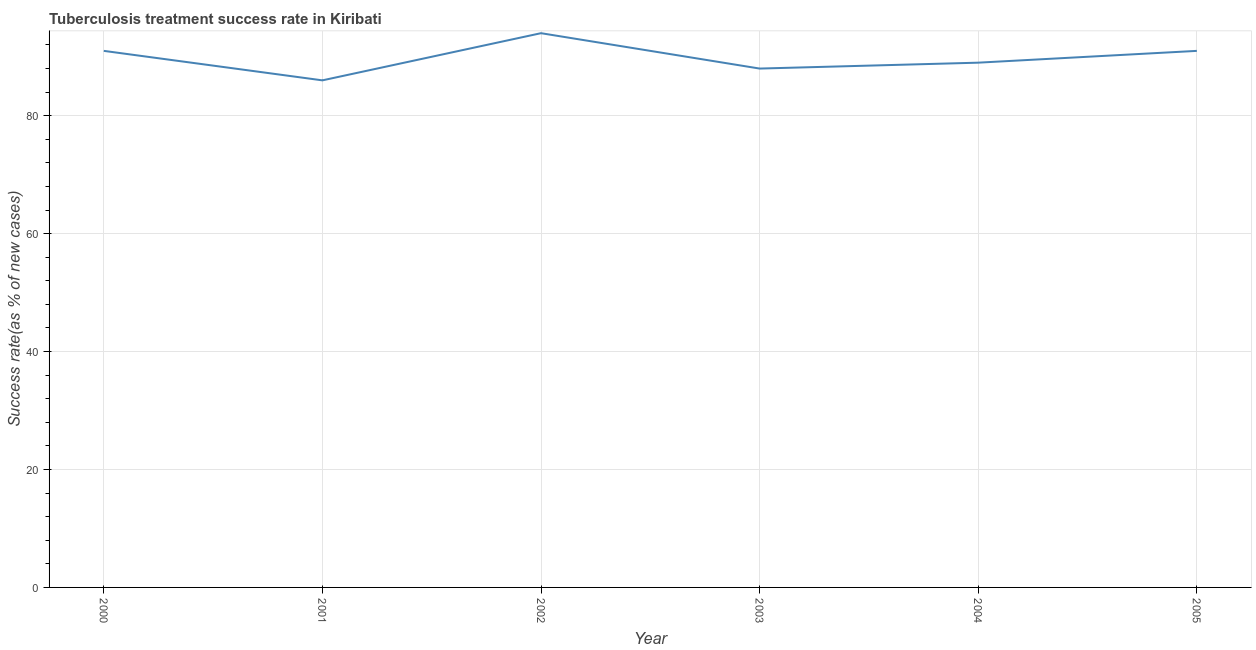What is the tuberculosis treatment success rate in 2001?
Make the answer very short. 86. Across all years, what is the maximum tuberculosis treatment success rate?
Offer a very short reply. 94. Across all years, what is the minimum tuberculosis treatment success rate?
Provide a succinct answer. 86. In which year was the tuberculosis treatment success rate minimum?
Keep it short and to the point. 2001. What is the sum of the tuberculosis treatment success rate?
Offer a terse response. 539. What is the difference between the tuberculosis treatment success rate in 2000 and 2005?
Your response must be concise. 0. What is the average tuberculosis treatment success rate per year?
Offer a terse response. 89.83. What is the median tuberculosis treatment success rate?
Your answer should be compact. 90. Do a majority of the years between 2001 and 2004 (inclusive) have tuberculosis treatment success rate greater than 68 %?
Offer a very short reply. Yes. What is the ratio of the tuberculosis treatment success rate in 2002 to that in 2005?
Offer a terse response. 1.03. Is the tuberculosis treatment success rate in 2001 less than that in 2003?
Ensure brevity in your answer.  Yes. Is the difference between the tuberculosis treatment success rate in 2001 and 2002 greater than the difference between any two years?
Give a very brief answer. Yes. What is the difference between the highest and the lowest tuberculosis treatment success rate?
Give a very brief answer. 8. In how many years, is the tuberculosis treatment success rate greater than the average tuberculosis treatment success rate taken over all years?
Give a very brief answer. 3. Does the tuberculosis treatment success rate monotonically increase over the years?
Provide a succinct answer. No. How many lines are there?
Provide a short and direct response. 1. How many years are there in the graph?
Your response must be concise. 6. Are the values on the major ticks of Y-axis written in scientific E-notation?
Give a very brief answer. No. Does the graph contain any zero values?
Give a very brief answer. No. What is the title of the graph?
Make the answer very short. Tuberculosis treatment success rate in Kiribati. What is the label or title of the Y-axis?
Make the answer very short. Success rate(as % of new cases). What is the Success rate(as % of new cases) in 2000?
Offer a terse response. 91. What is the Success rate(as % of new cases) in 2001?
Provide a succinct answer. 86. What is the Success rate(as % of new cases) in 2002?
Your answer should be very brief. 94. What is the Success rate(as % of new cases) in 2003?
Provide a short and direct response. 88. What is the Success rate(as % of new cases) in 2004?
Offer a very short reply. 89. What is the Success rate(as % of new cases) in 2005?
Your answer should be very brief. 91. What is the difference between the Success rate(as % of new cases) in 2000 and 2003?
Make the answer very short. 3. What is the difference between the Success rate(as % of new cases) in 2001 and 2005?
Make the answer very short. -5. What is the difference between the Success rate(as % of new cases) in 2002 and 2005?
Your answer should be very brief. 3. What is the difference between the Success rate(as % of new cases) in 2003 and 2004?
Your response must be concise. -1. What is the difference between the Success rate(as % of new cases) in 2003 and 2005?
Give a very brief answer. -3. What is the ratio of the Success rate(as % of new cases) in 2000 to that in 2001?
Make the answer very short. 1.06. What is the ratio of the Success rate(as % of new cases) in 2000 to that in 2003?
Ensure brevity in your answer.  1.03. What is the ratio of the Success rate(as % of new cases) in 2001 to that in 2002?
Provide a short and direct response. 0.92. What is the ratio of the Success rate(as % of new cases) in 2001 to that in 2005?
Ensure brevity in your answer.  0.94. What is the ratio of the Success rate(as % of new cases) in 2002 to that in 2003?
Your response must be concise. 1.07. What is the ratio of the Success rate(as % of new cases) in 2002 to that in 2004?
Your answer should be very brief. 1.06. What is the ratio of the Success rate(as % of new cases) in 2002 to that in 2005?
Your response must be concise. 1.03. 